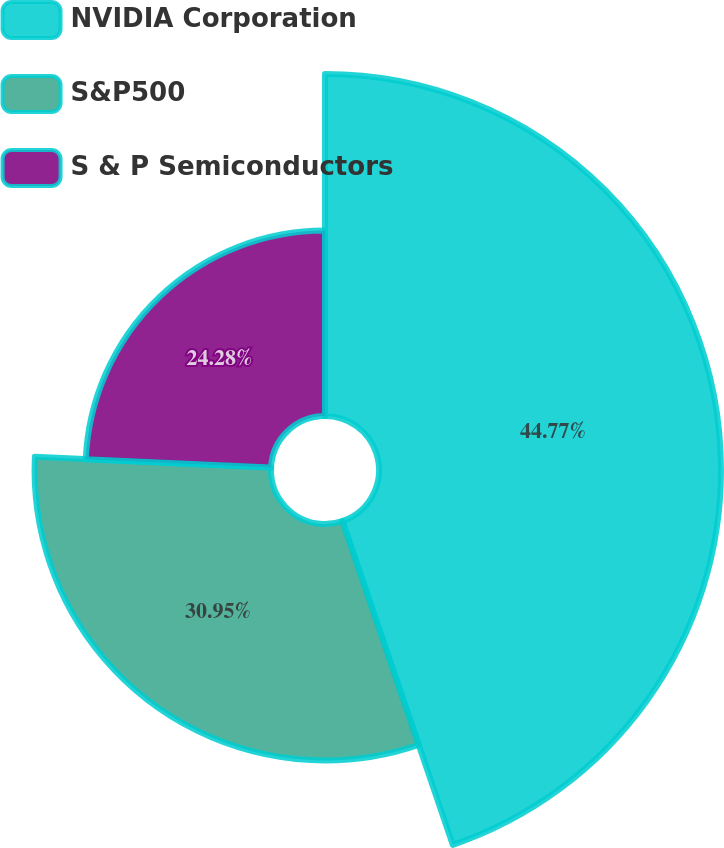Convert chart to OTSL. <chart><loc_0><loc_0><loc_500><loc_500><pie_chart><fcel>NVIDIA Corporation<fcel>S&P500<fcel>S & P Semiconductors<nl><fcel>44.77%<fcel>30.95%<fcel>24.28%<nl></chart> 